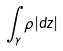Convert formula to latex. <formula><loc_0><loc_0><loc_500><loc_500>\int _ { \gamma } \rho | d z |</formula> 